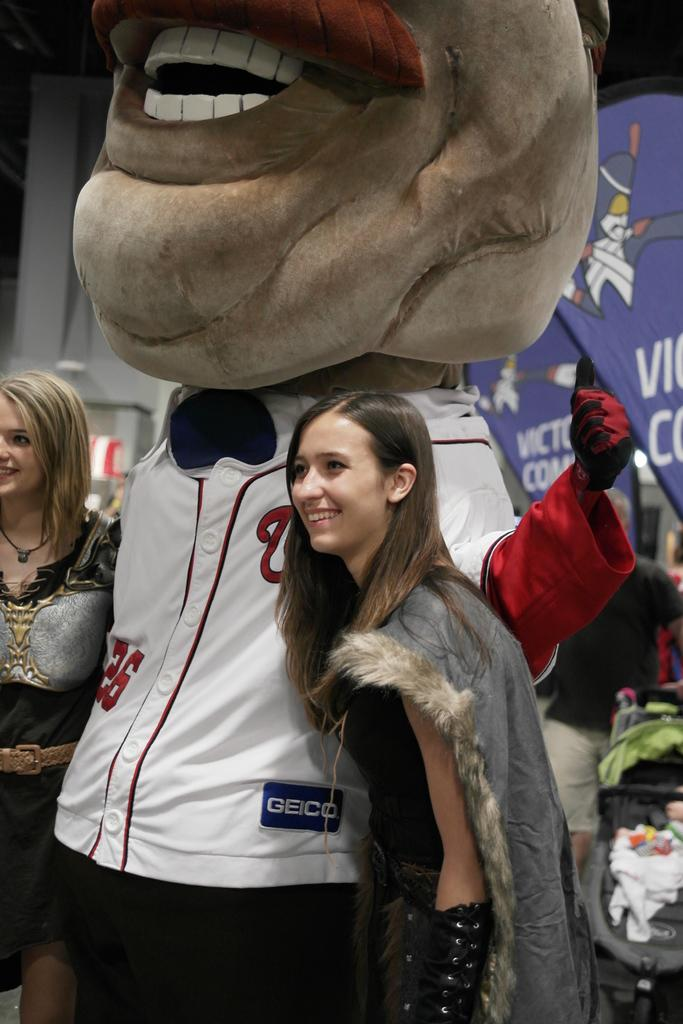<image>
Render a clear and concise summary of the photo. A large mascot wearing its team jersey sponsored by Geico takes a picture with a young woman. 